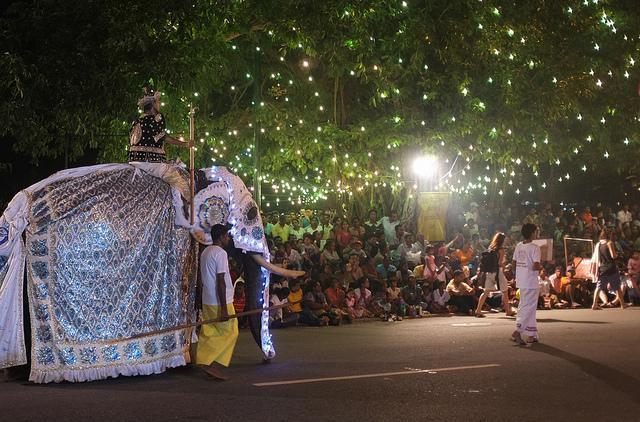How many people are visible?
Give a very brief answer. 3. How many trains are moving?
Give a very brief answer. 0. 